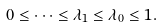Convert formula to latex. <formula><loc_0><loc_0><loc_500><loc_500>0 \leq \dots \leq \lambda _ { 1 } \leq \lambda _ { 0 } \leq 1 .</formula> 